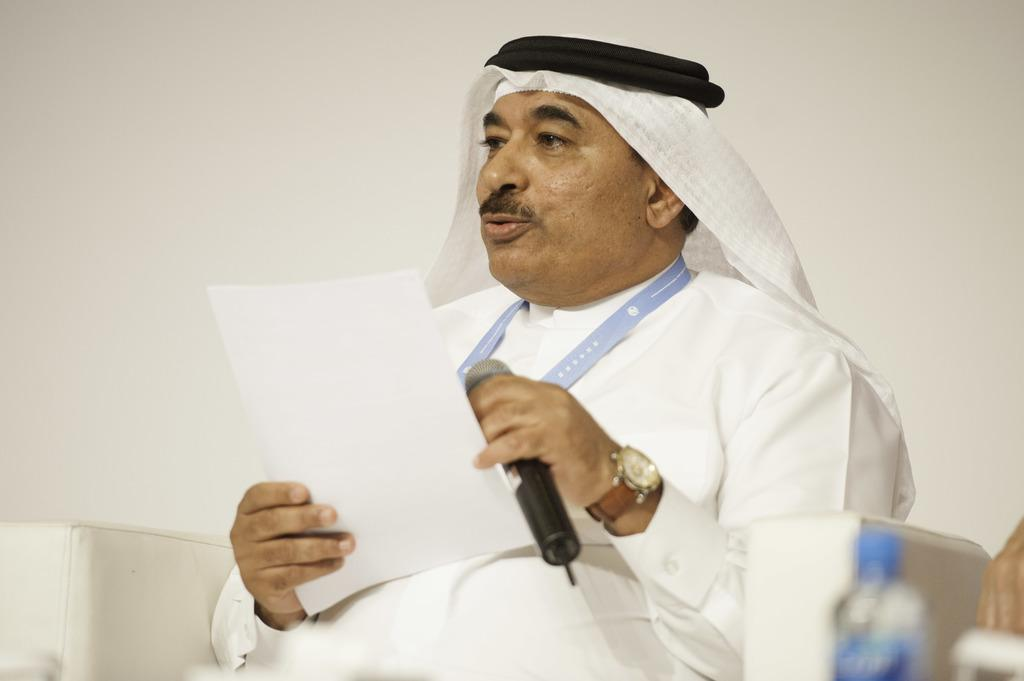What is the person in the image doing? The person is sitting in the image and holding a microphone. Can you describe the object the person is holding? The person is holding a microphone, which is typically used for amplifying sound or recording speech. What else can be seen on the left side of the image? There is a bottle on the left side of the image. What type of trade is being conducted in the image? There is no indication of any trade being conducted in the image; it primarily features a person holding a microphone and a bottle on the left side. 